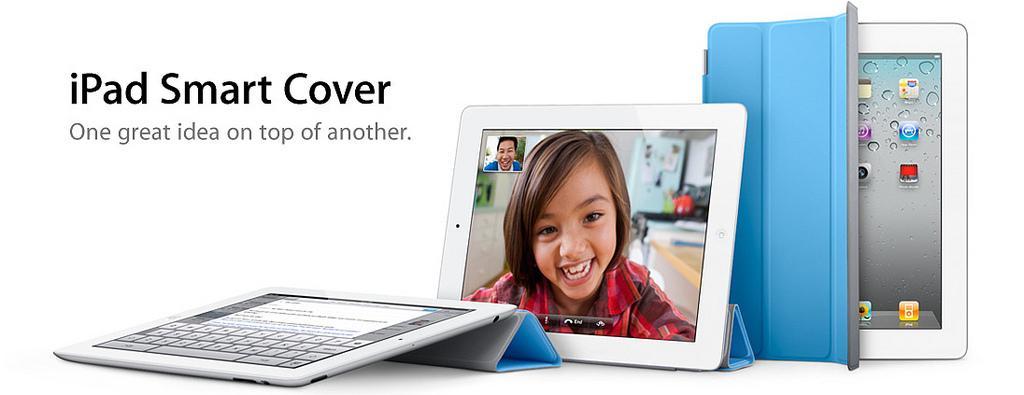How would you summarize this image in a sentence or two? In this we can see two iPads and one mobile phone. We can also see the iPad with a virtual keyboard screen and the other iPad with a girl and also a person and the mobile phone is showing some icons. We can also see the text and the background of the image is in white color. 